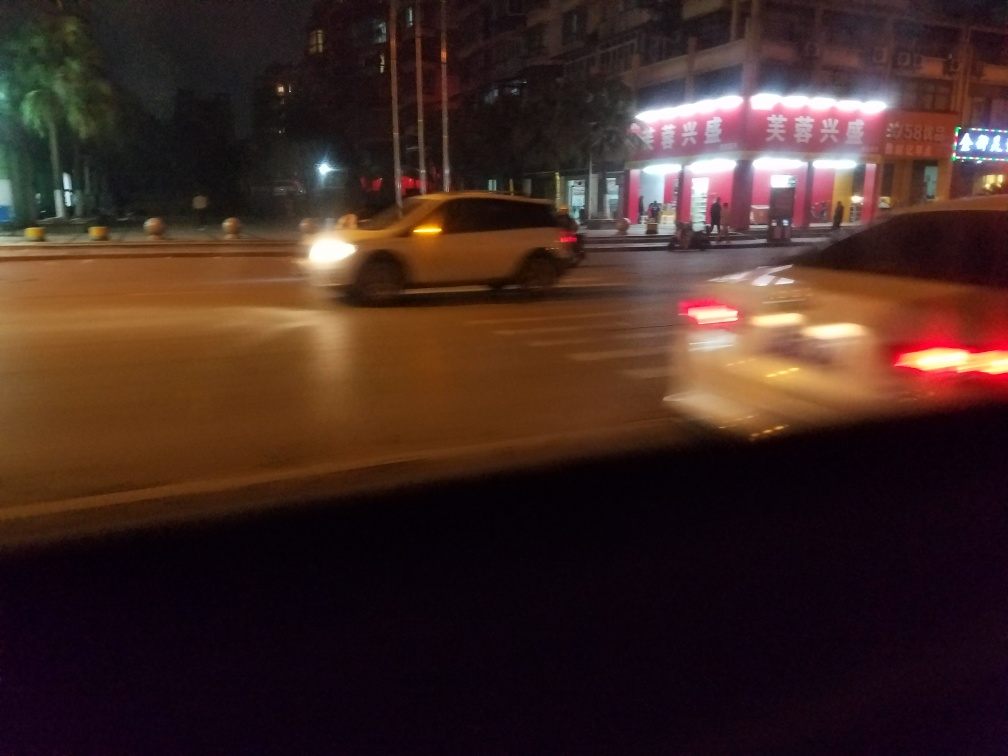Can you infer anything about the weather conditions at the time this photo was taken? The photo doesn't show rain or snow, and the street surface does not appear to reflect weather conditions like puddles or snow. However, the image is blurred, and no weather conditions can be determined conclusively. The general ambiance suggests clear but dark conditions, typical of a city at night without active precipitation. 